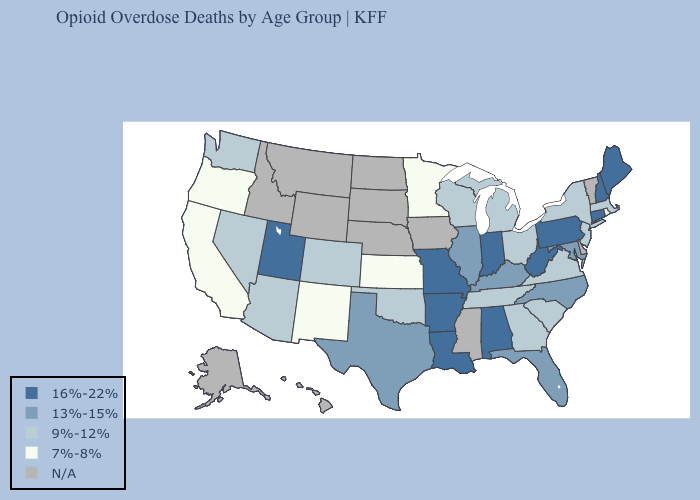Does Arizona have the lowest value in the West?
Write a very short answer. No. What is the value of Idaho?
Quick response, please. N/A. Name the states that have a value in the range 7%-8%?
Be succinct. California, Kansas, Minnesota, New Mexico, Oregon, Rhode Island. What is the highest value in the Northeast ?
Quick response, please. 16%-22%. Name the states that have a value in the range N/A?
Quick response, please. Alaska, Delaware, Hawaii, Idaho, Iowa, Mississippi, Montana, Nebraska, North Dakota, South Dakota, Vermont, Wyoming. What is the value of Alaska?
Concise answer only. N/A. What is the value of Delaware?
Concise answer only. N/A. Name the states that have a value in the range 13%-15%?
Quick response, please. Florida, Illinois, Kentucky, Maryland, North Carolina, Texas. Among the states that border Texas , does New Mexico have the lowest value?
Answer briefly. Yes. Name the states that have a value in the range 13%-15%?
Give a very brief answer. Florida, Illinois, Kentucky, Maryland, North Carolina, Texas. Name the states that have a value in the range N/A?
Write a very short answer. Alaska, Delaware, Hawaii, Idaho, Iowa, Mississippi, Montana, Nebraska, North Dakota, South Dakota, Vermont, Wyoming. Name the states that have a value in the range 16%-22%?
Write a very short answer. Alabama, Arkansas, Connecticut, Indiana, Louisiana, Maine, Missouri, New Hampshire, Pennsylvania, Utah, West Virginia. Does West Virginia have the lowest value in the USA?
Write a very short answer. No. Which states have the highest value in the USA?
Be succinct. Alabama, Arkansas, Connecticut, Indiana, Louisiana, Maine, Missouri, New Hampshire, Pennsylvania, Utah, West Virginia. 